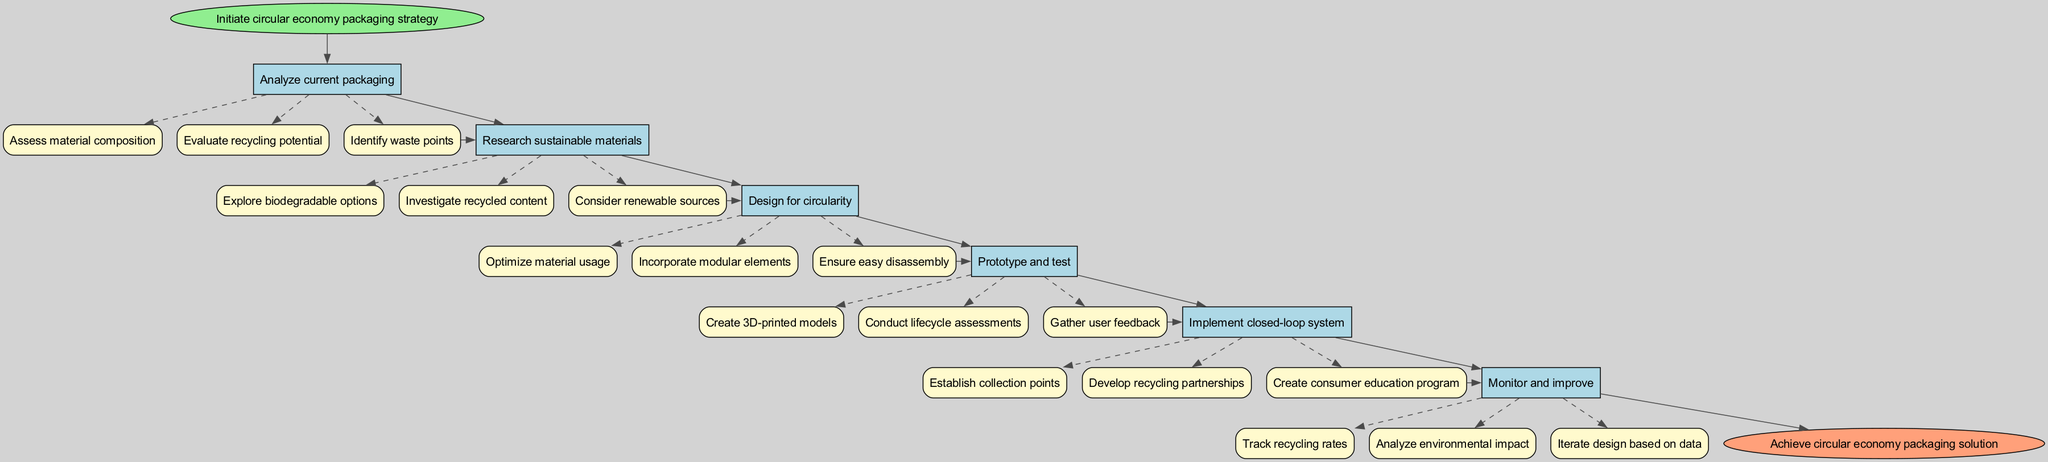What is the first step in the process? The first step in the diagram, represented at the start node, is "Initiate circular economy packaging strategy".
Answer: Initiate circular economy packaging strategy How many steps are there in total? Counting all the main steps listed in the diagram, there are six steps in total prior to the end node.
Answer: 6 What is the last step before achieving the end goal? The last step before the end node is "Monitor and improve". This step feeds directly into the final node.
Answer: Monitor and improve How many substeps are associated with "Research sustainable materials"? The step "Research sustainable materials" has three defined substeps: "Explore biodegradable options," "Investigate recycled content," and "Consider renewable sources."
Answer: 3 What is the relationship between "Prototype and test" and "Implement closed-loop system"? The relationship is that "Prototype and test" leads directly into "Implement closed-loop system" as it is the step that occurs immediately before it in the flow of the diagram.
Answer: Directly leads to Which substep under "Design for circularity" focuses on materials? The substep "Optimize material usage" specifically addresses the efficient use of materials in the design for circularity.
Answer: Optimize material usage What is the final output of the diagram? The output of the diagram concludes with achieving the "circular economy packaging solution", indicated at the end node.
Answer: Achieve circular economy packaging solution What type of design elements are encouraged in the "Design for circularity" step? The "Design for circularity" step encourages "modular elements" as a key aspect of its design principles.
Answer: Modular elements What does the "Implement closed-loop system" step create for consumers? This step creates a "consumer education program," which is aimed at informing consumers about recycling and sustainability practices.
Answer: Consumer education program 